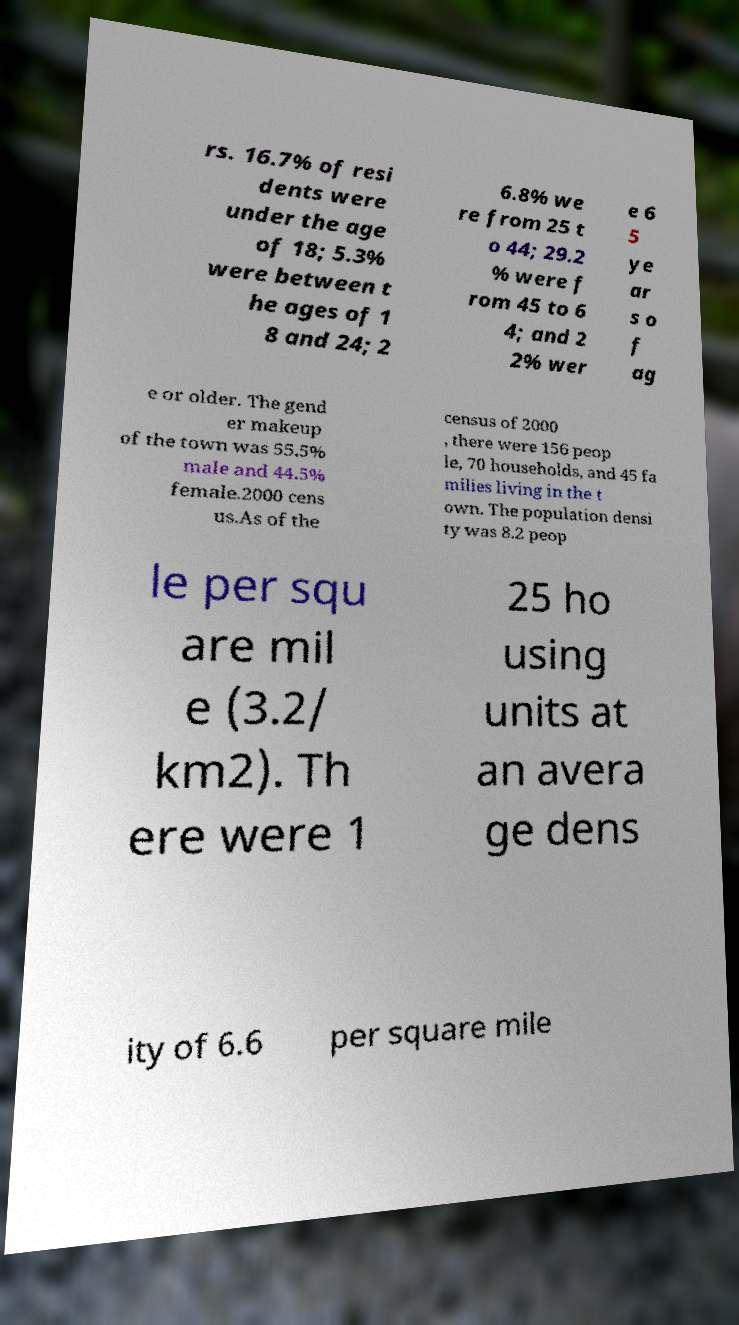What messages or text are displayed in this image? I need them in a readable, typed format. rs. 16.7% of resi dents were under the age of 18; 5.3% were between t he ages of 1 8 and 24; 2 6.8% we re from 25 t o 44; 29.2 % were f rom 45 to 6 4; and 2 2% wer e 6 5 ye ar s o f ag e or older. The gend er makeup of the town was 55.5% male and 44.5% female.2000 cens us.As of the census of 2000 , there were 156 peop le, 70 households, and 45 fa milies living in the t own. The population densi ty was 8.2 peop le per squ are mil e (3.2/ km2). Th ere were 1 25 ho using units at an avera ge dens ity of 6.6 per square mile 